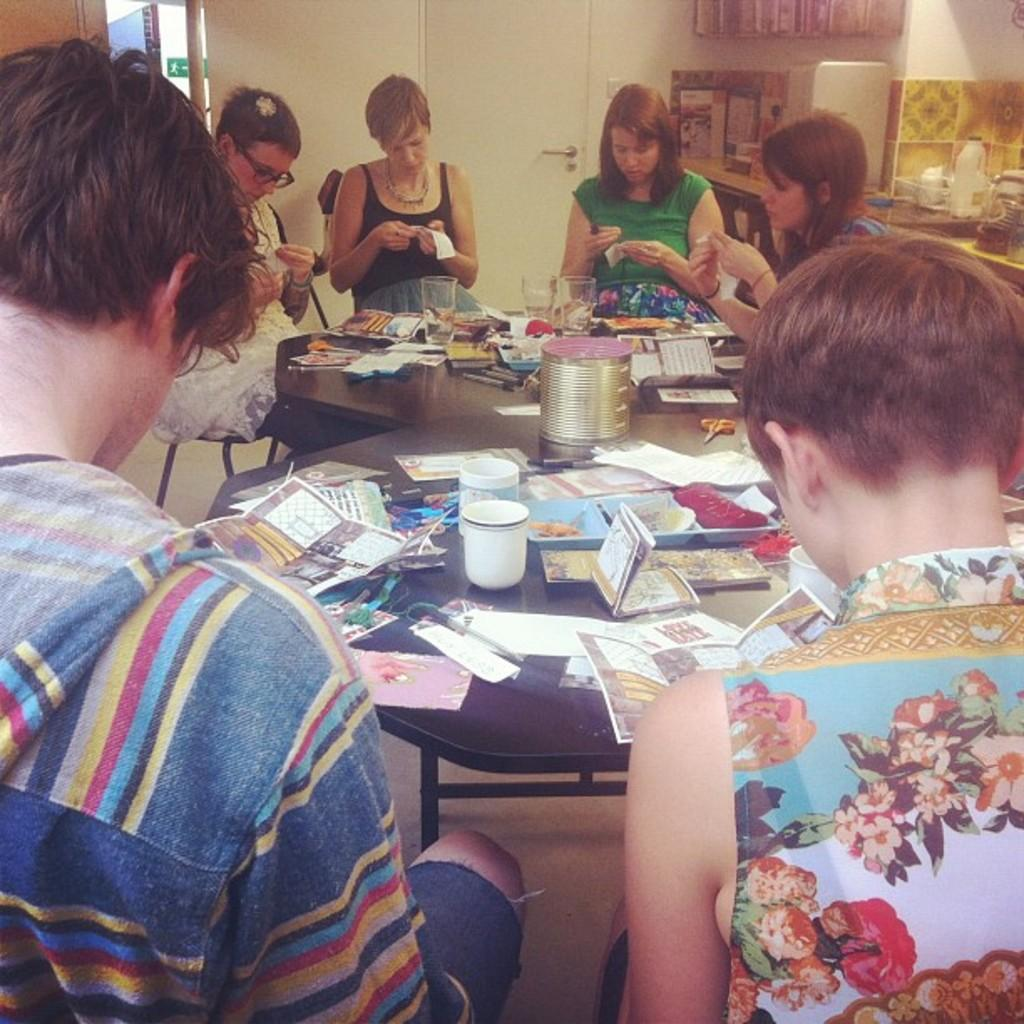What are the people in the image doing? The people in the image are seated on chairs. What objects are on the tables in the image? There are papers and glasses on the tables in the image. What can be seen in the background of the image? There is a door visible in the image. What accessory is the woman wearing in the image? The woman is wearing spectacles in the image. What type of wool is being used to clean the glasses in the image? There is no wool present in the image, and the glasses are not being cleaned. 